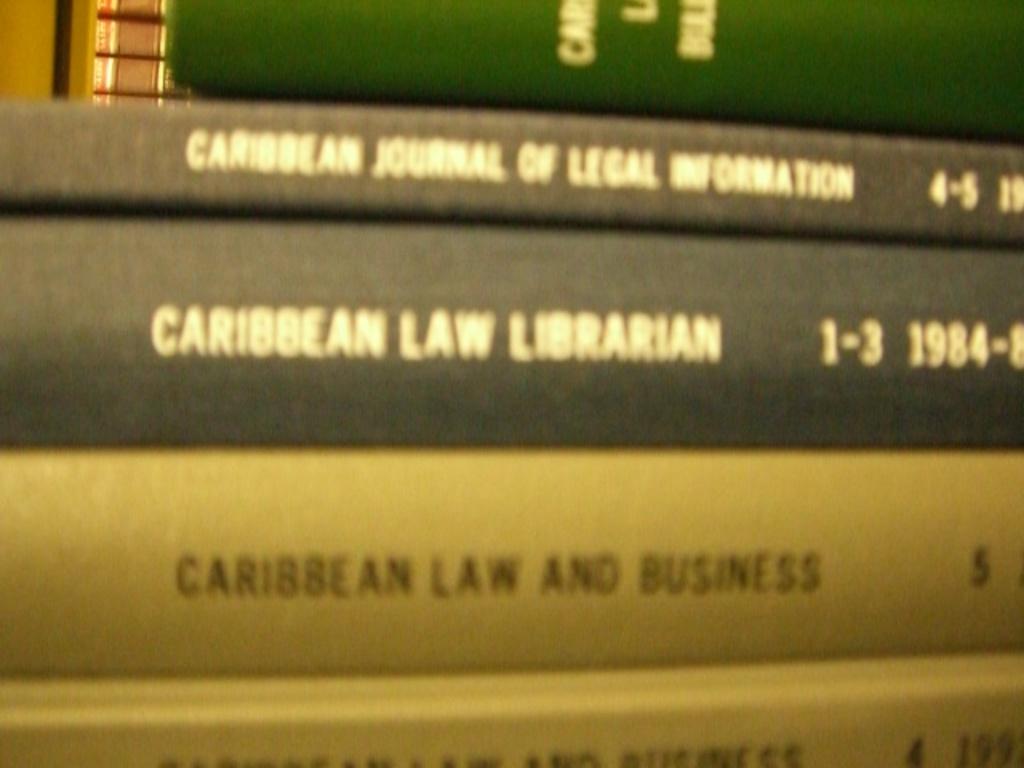What is the date for caribbean law librarian?
Keep it short and to the point. 1984. What is the title of the cream colored book?
Your answer should be compact. Caribbean law and business. 